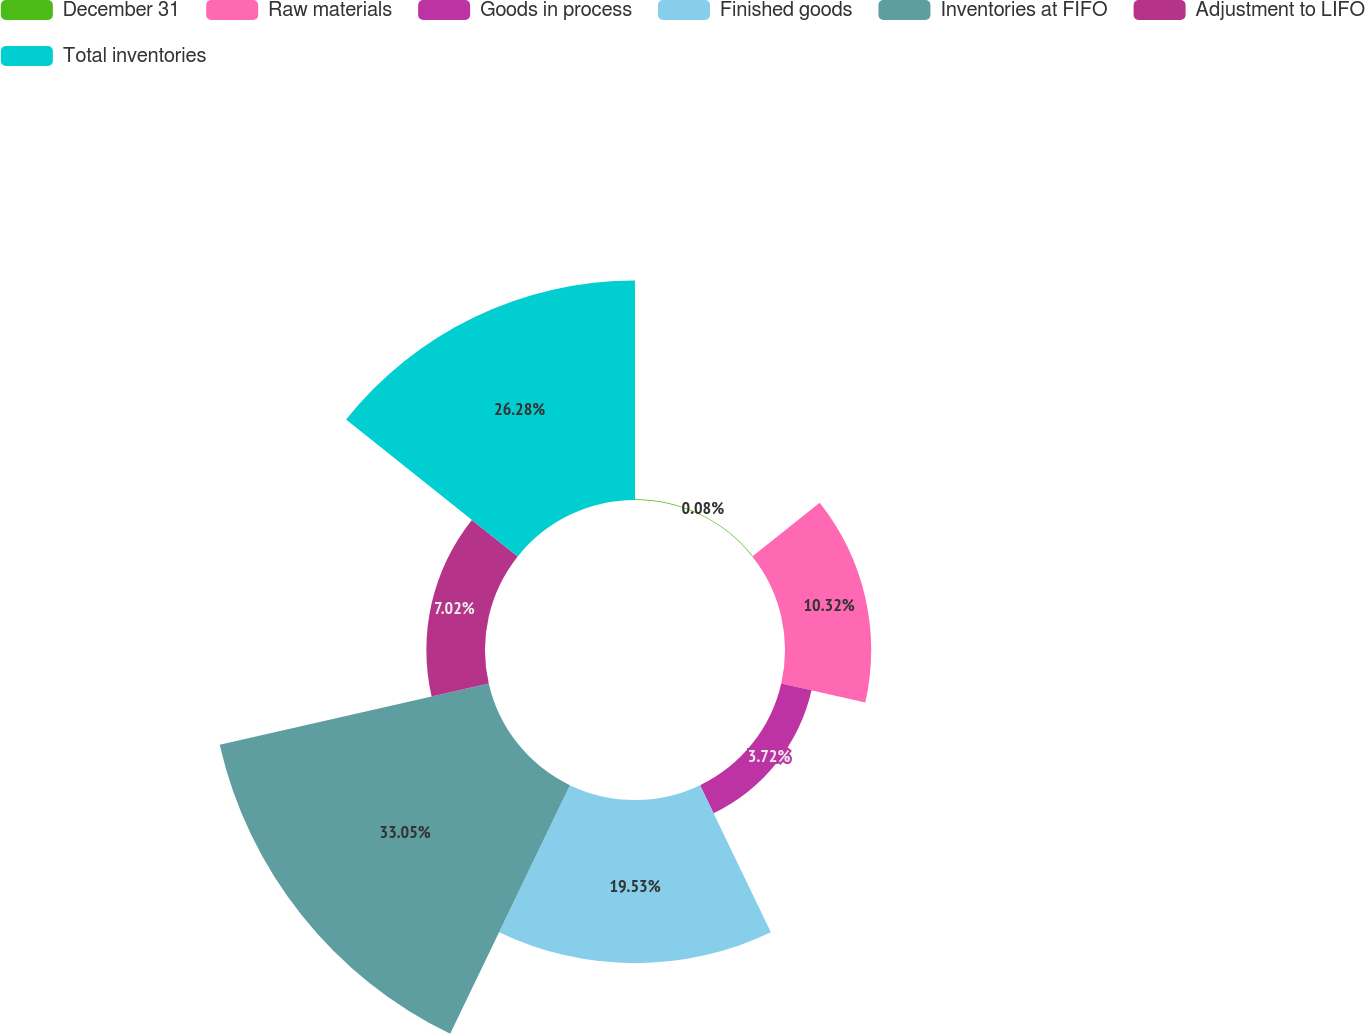Convert chart. <chart><loc_0><loc_0><loc_500><loc_500><pie_chart><fcel>December 31<fcel>Raw materials<fcel>Goods in process<fcel>Finished goods<fcel>Inventories at FIFO<fcel>Adjustment to LIFO<fcel>Total inventories<nl><fcel>0.08%<fcel>10.32%<fcel>3.72%<fcel>19.53%<fcel>33.04%<fcel>7.02%<fcel>26.28%<nl></chart> 